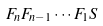<formula> <loc_0><loc_0><loc_500><loc_500>F _ { n } F _ { n - 1 } \cdots F _ { 1 } S</formula> 